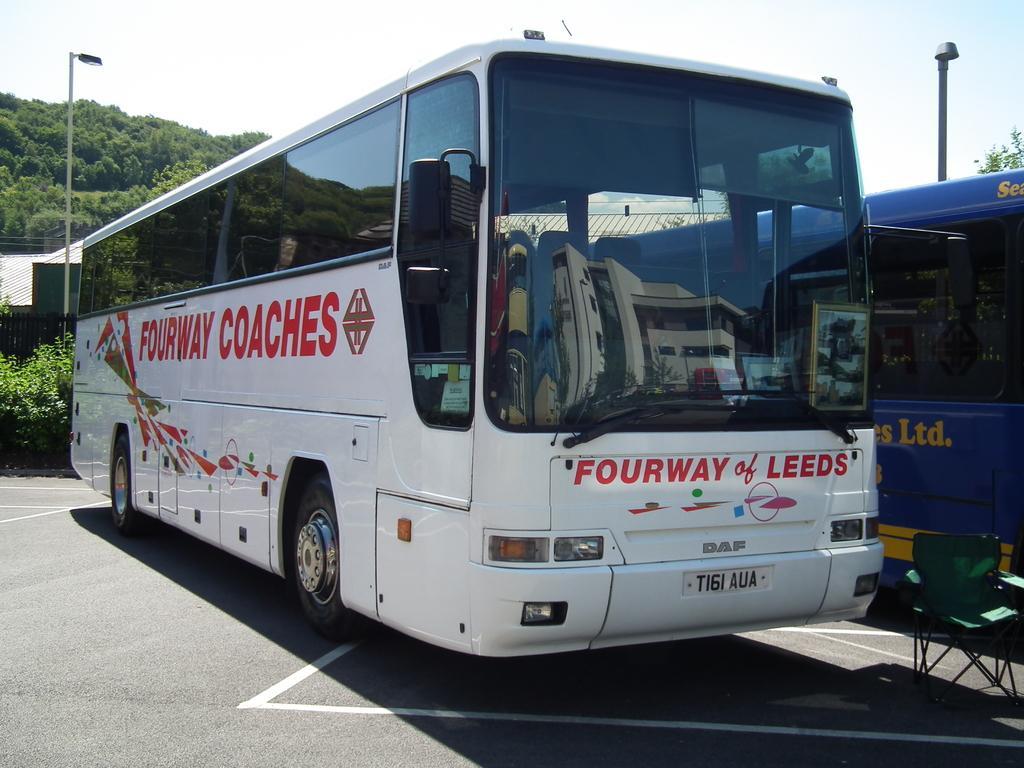Describe this image in one or two sentences. In the picture I can see two buses among them the bus on the left side is white in color. In the background I can see street lights, trees and the sky. I can also see a chair on the road. 